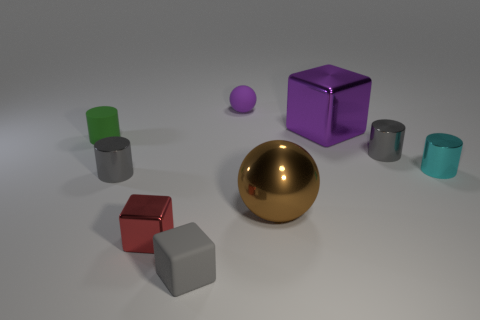Are there fewer large green metallic balls than small green objects?
Your answer should be very brief. Yes. What color is the small rubber thing that is the same shape as the big brown thing?
Your answer should be very brief. Purple. Is there any other thing that is the same shape as the big purple thing?
Your answer should be compact. Yes. Is the number of big purple metal things greater than the number of blocks?
Provide a succinct answer. No. What number of other things are there of the same material as the tiny green object
Keep it short and to the point. 2. There is a rubber object behind the shiny block on the right side of the tiny matte thing behind the rubber cylinder; what is its shape?
Provide a short and direct response. Sphere. Are there fewer large brown shiny balls in front of the large metal ball than tiny green things that are behind the cyan object?
Offer a terse response. Yes. Are there any tiny cylinders of the same color as the big shiny cube?
Your answer should be very brief. No. Does the red thing have the same material as the sphere on the left side of the big brown shiny thing?
Provide a succinct answer. No. There is a shiny cube right of the red block; is there a purple thing that is behind it?
Your answer should be very brief. Yes. 